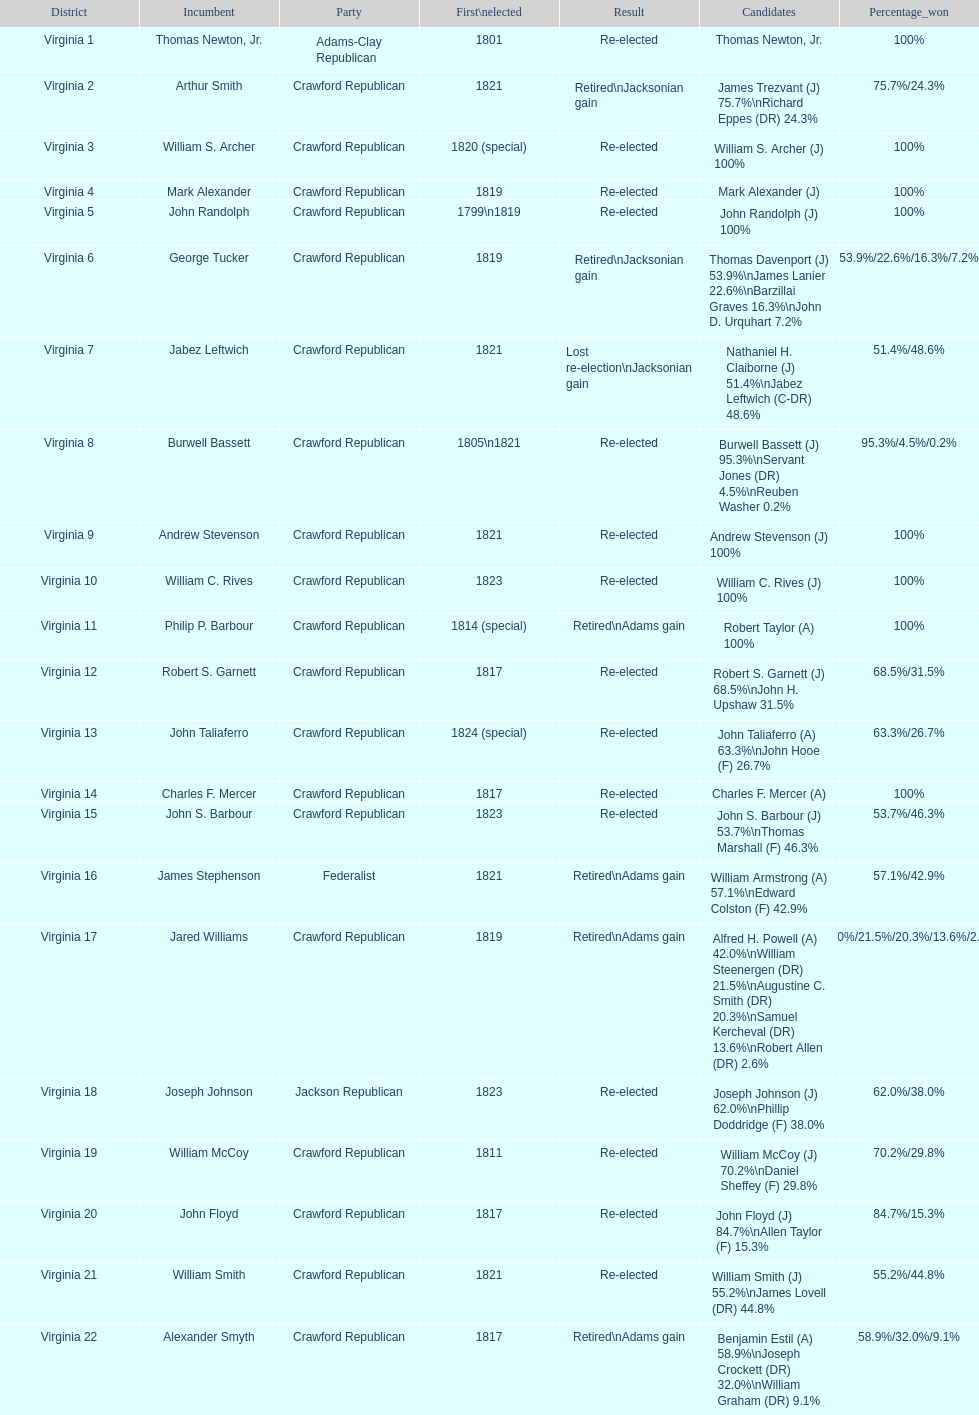Number of incumbents who retired or lost re-election 7. 